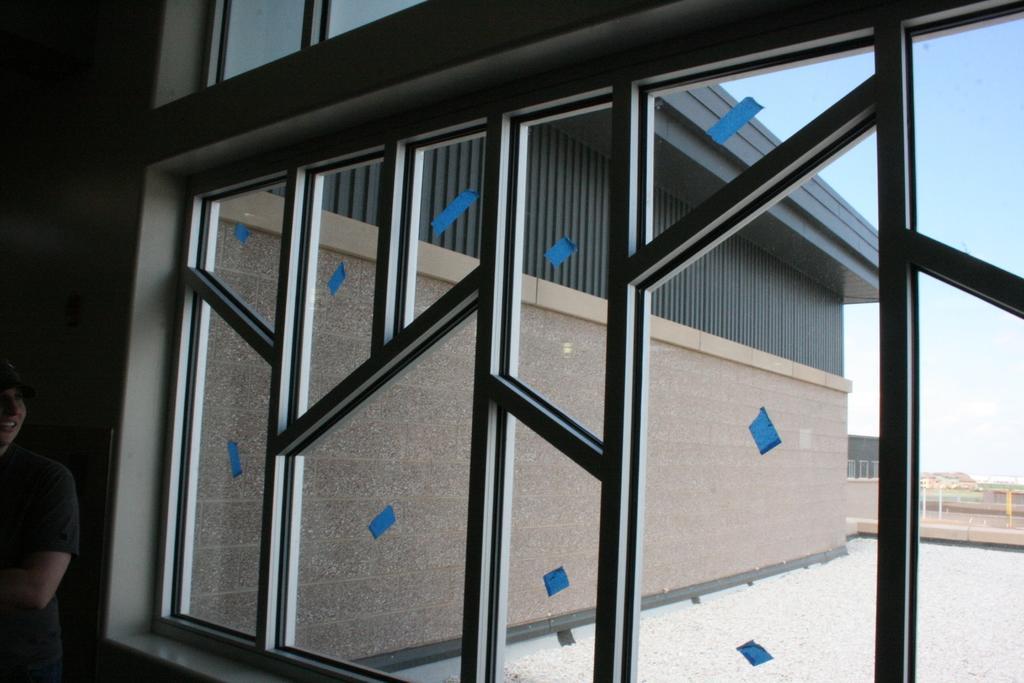In one or two sentences, can you explain what this image depicts? In this image there is a glass window to a building. Outside the window there are houses and a fence. At the top there is the sky. To the left there is a person standing. 